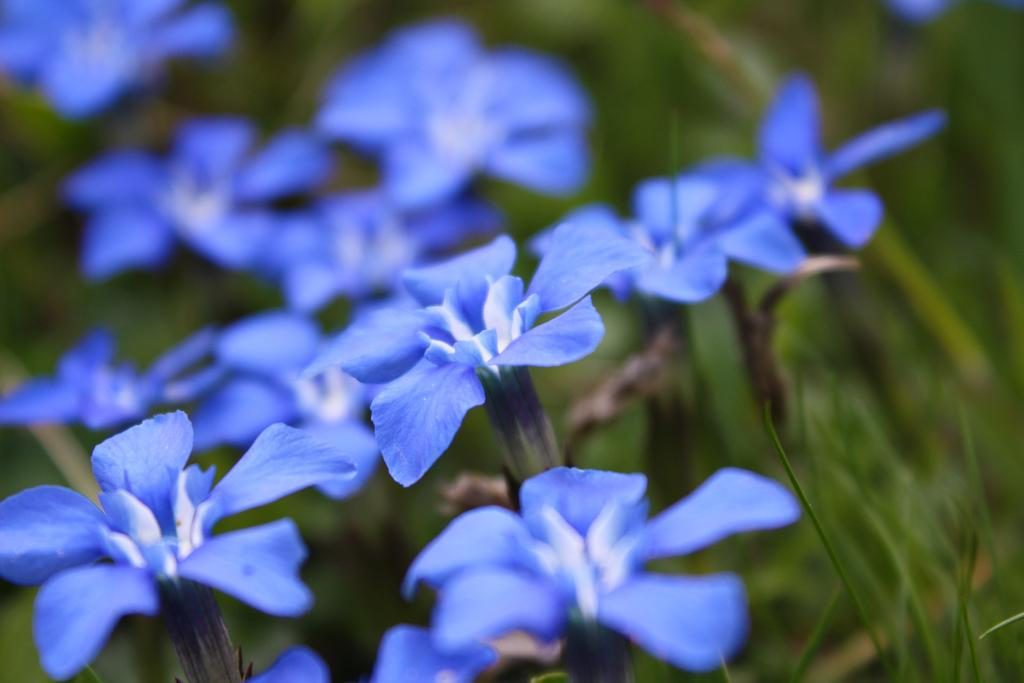What type of flora is present in the image? There are flowers in the image. What color are the flowers? The flowers are purple. What celestial bodies can be seen in the image? There are planets visible in the image. Can you describe the background of the image? The background of the image is blurred. What type of tramp can be seen jumping over the icicle in the image? There is no tramp or icicle present in the image. 